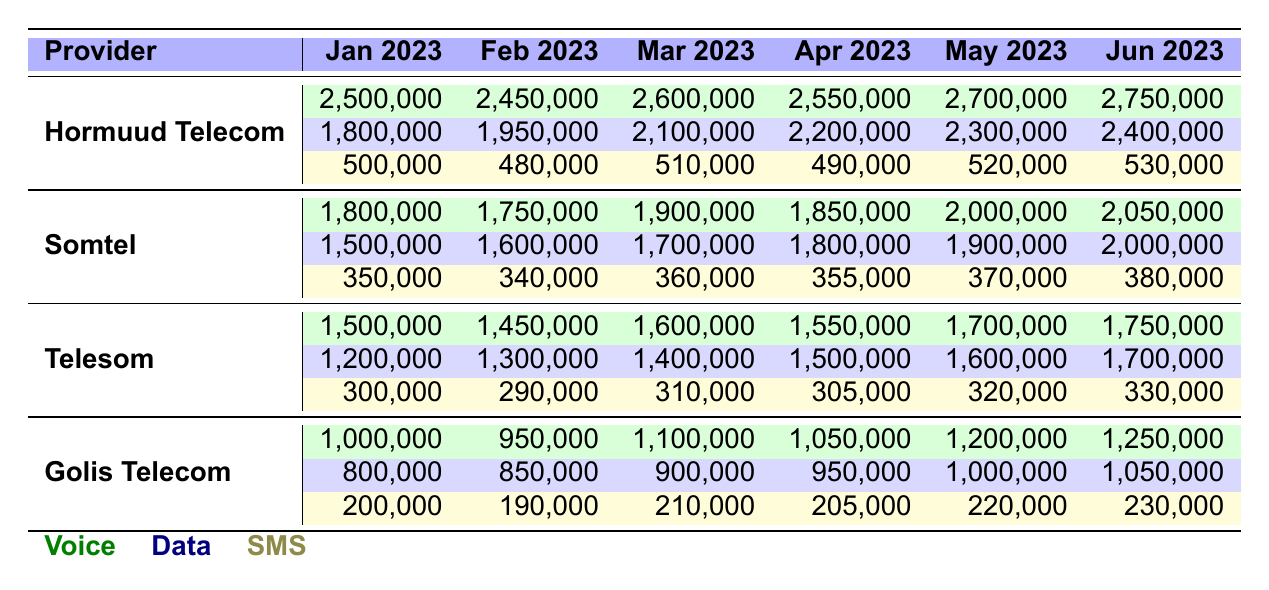What was Hormuud Telecom's total revenue from voice services in March 2023? Hormuud Telecom's revenue from voice services in March 2023 is 2,600,000.
Answer: 2,600,000 Which provider had the highest total revenue from data services in June 2023? In June 2023, Hormuud Telecom had the highest total revenue from data services, which is 2,400,000.
Answer: Hormuud Telecom What is the average revenue from SMS services for Somtel over the six months? Somtel's SMS revenues over the six months are 350,000, 340,000, 360,000, 355,000, 370,000, and 380,000. The average is calculated as (350,000 + 340,000 + 360,000 + 355,000 + 370,000 + 380,000) / 6 = 358,333.33.
Answer: 358,333.33 Did Golis Telecom's revenue from data services increase every month from January to June 2023? Golis Telecom had the following data revenue: 800,000 (Jan), 850,000 (Feb), 900,000 (Mar), 950,000 (Apr), 1,000,000 (May), and 1,050,000 (Jun), which shows continuous increase.
Answer: Yes What was the difference between the total voice revenue of Telesom and Golis Telecom in May 2023? Telesom's voice revenue in May 2023 was 1,700,000 while Golis Telecom's was 1,200,000, so the difference is 1,700,000 - 1,200,000 = 500,000.
Answer: 500,000 Which service type generated the lowest revenue for Hormuud Telecom in April 2023? In April 2023, Hormuud Telecom's SMS revenue was the lowest at 490,000 compared to its voice and data revenues.
Answer: SMS What was the total revenue from voice services for all providers in January 2023? The total voice revenue for January 2023 is calculated as follows: Hormuud (2,500,000) + Somtel (1,800,000) + Telesom (1,500,000) + Golis (1,000,000) = 6,800,000.
Answer: 6,800,000 Which month saw the highest revenue from SMS services across all providers? By comparing SMS revenues across all months, June 2023 has the highest total with 530,000 (Hormuud) + 380,000 (Somtel) + 330,000 (Telesom) + 230,000 (Golis) = 1,470,000.
Answer: June 2023 How much did Somtel earn from data services in February 2023? Somtel's revenue from data services in February 2023 is 1,600,000.
Answer: 1,600,000 What is the cumulative revenue from all services for Telesom for the first quarter of 2023? For Telesom: January (2,300,000), February (2,350,000), March (2,410,000). The cumulative revenue is 2,300,000 + 2,350,000 + 2,410,000 = 7,060,000.
Answer: 7,060,000 Which provider had the largest increase in voice revenue from January to June 2023? Hormuud Telecom increased from 2,500,000 (Jan) to 2,750,000 (Jun), a change of 250,000. When checking all providers, Hormuud Telecom had the largest increase.
Answer: Hormuud Telecom 